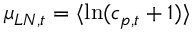Convert formula to latex. <formula><loc_0><loc_0><loc_500><loc_500>\mu _ { L N , t } = \langle \ln ( c _ { p , t } + 1 ) \rangle</formula> 